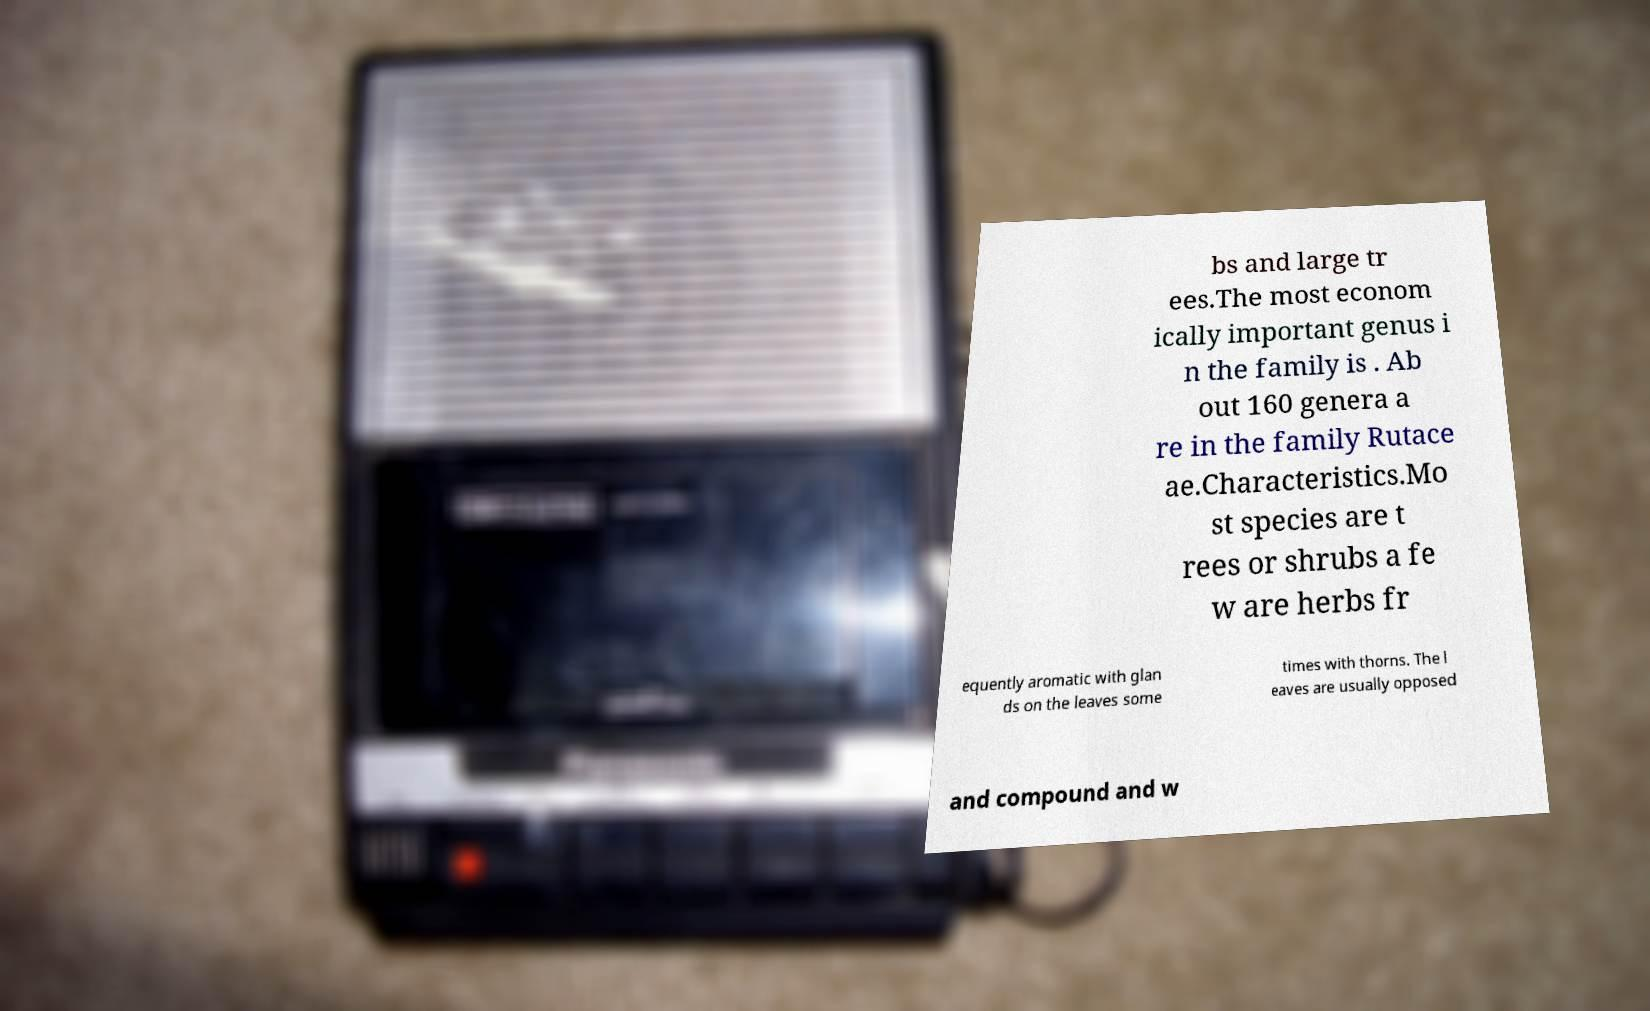Can you accurately transcribe the text from the provided image for me? bs and large tr ees.The most econom ically important genus i n the family is . Ab out 160 genera a re in the family Rutace ae.Characteristics.Mo st species are t rees or shrubs a fe w are herbs fr equently aromatic with glan ds on the leaves some times with thorns. The l eaves are usually opposed and compound and w 